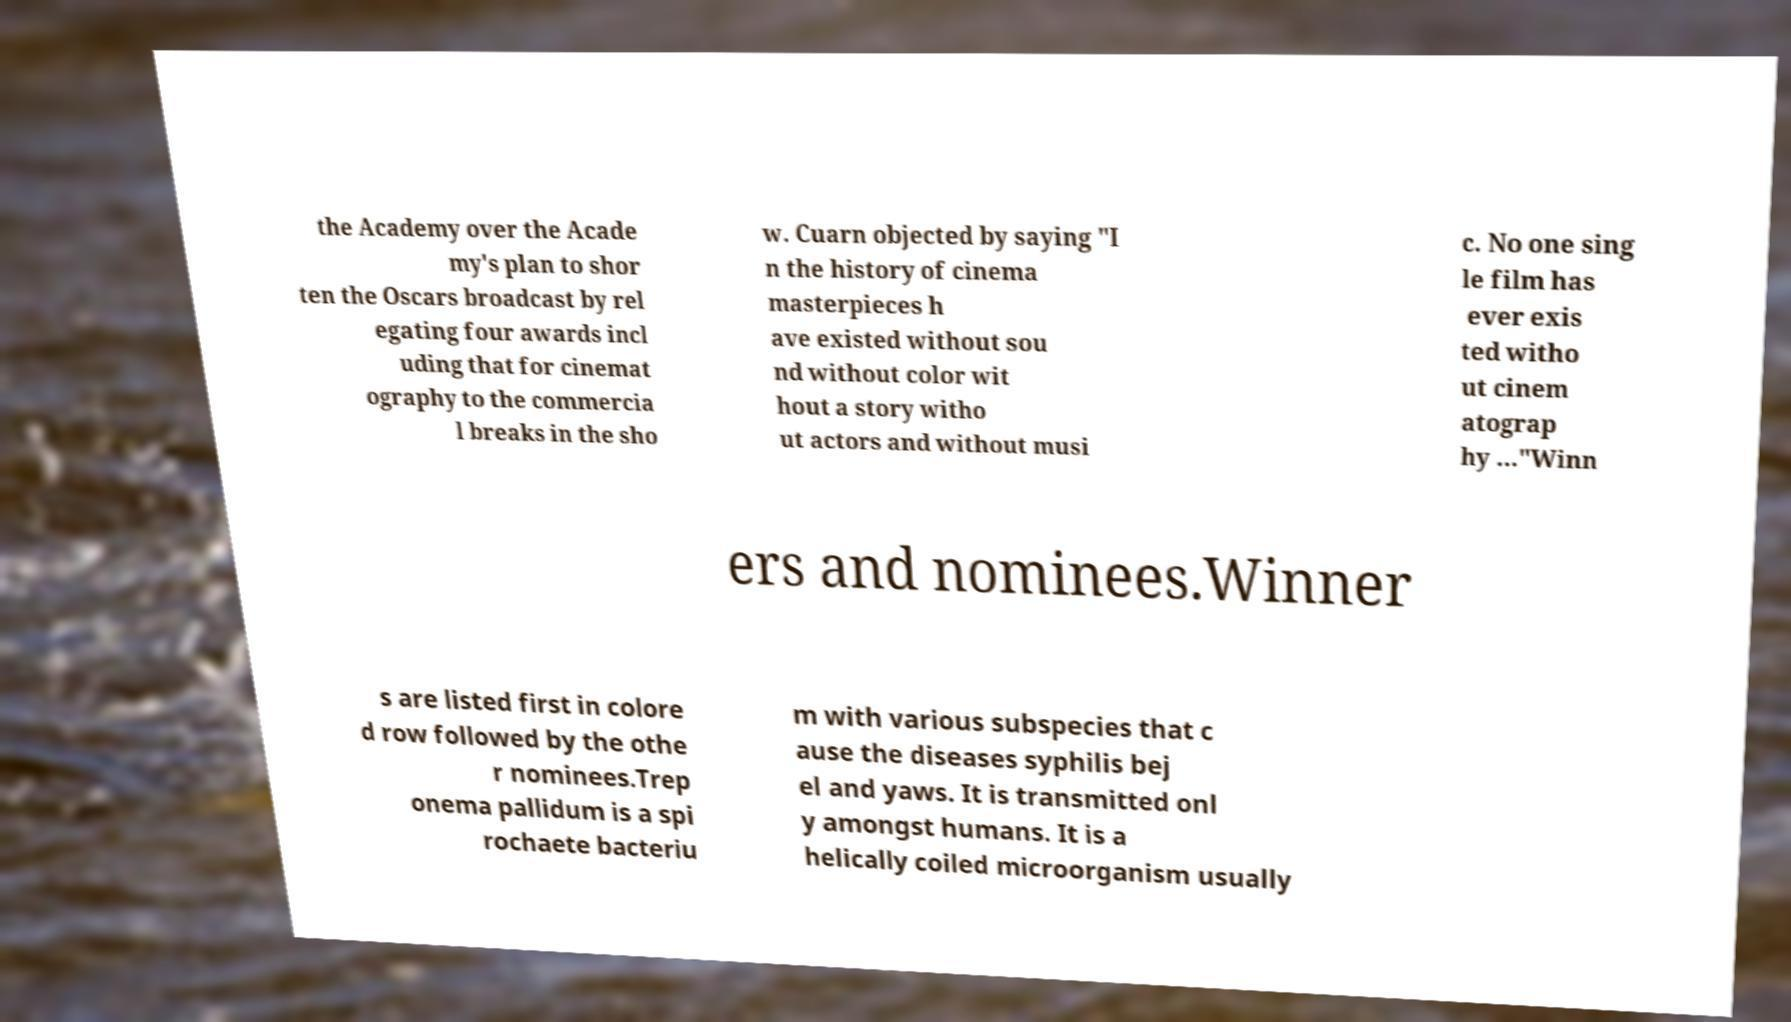Could you assist in decoding the text presented in this image and type it out clearly? the Academy over the Acade my's plan to shor ten the Oscars broadcast by rel egating four awards incl uding that for cinemat ography to the commercia l breaks in the sho w. Cuarn objected by saying "I n the history of cinema masterpieces h ave existed without sou nd without color wit hout a story witho ut actors and without musi c. No one sing le film has ever exis ted witho ut cinem atograp hy ..."Winn ers and nominees.Winner s are listed first in colore d row followed by the othe r nominees.Trep onema pallidum is a spi rochaete bacteriu m with various subspecies that c ause the diseases syphilis bej el and yaws. It is transmitted onl y amongst humans. It is a helically coiled microorganism usually 